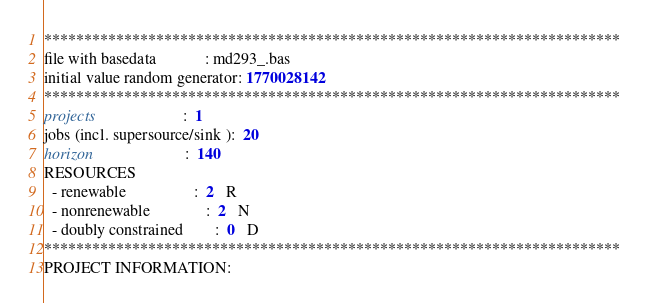Convert code to text. <code><loc_0><loc_0><loc_500><loc_500><_ObjectiveC_>************************************************************************
file with basedata            : md293_.bas
initial value random generator: 1770028142
************************************************************************
projects                      :  1
jobs (incl. supersource/sink ):  20
horizon                       :  140
RESOURCES
  - renewable                 :  2   R
  - nonrenewable              :  2   N
  - doubly constrained        :  0   D
************************************************************************
PROJECT INFORMATION:</code> 